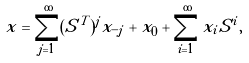Convert formula to latex. <formula><loc_0><loc_0><loc_500><loc_500>x = \sum _ { j = 1 } ^ { \infty } ( S ^ { T } ) ^ { j } x _ { - j } + x _ { 0 } + \sum _ { i = 1 } ^ { \infty } x _ { i } S ^ { i } ,</formula> 